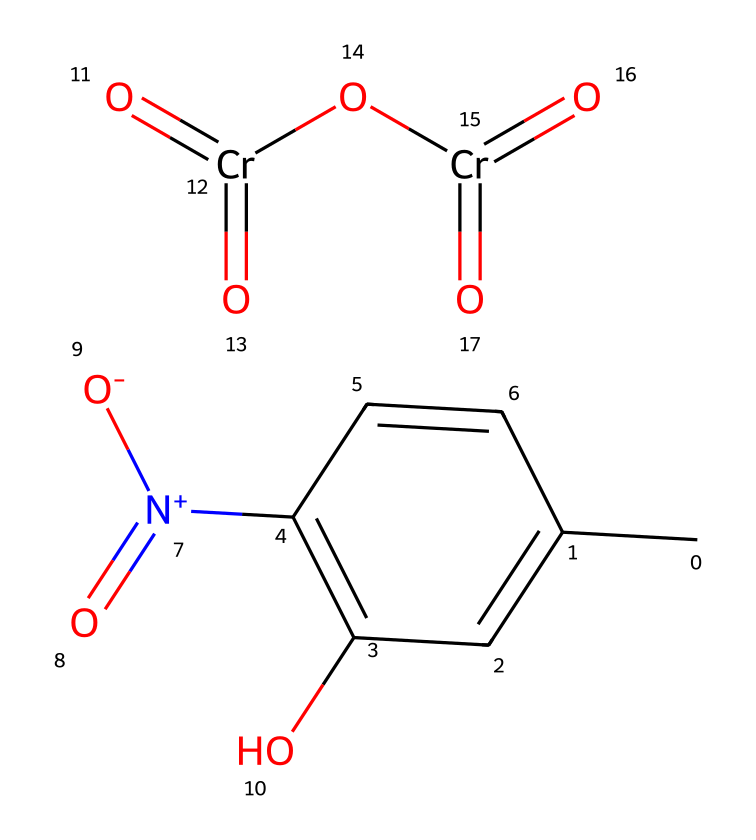What is the main color indicated by the presence of chromium in this chemical? The chromium atoms are often associated with green coloring in ceramics due to their oxidation states and how they absorb visible light.
Answer: green How many nitrogen atoms are present in this chemical? By analyzing the SMILES representation, there is one nitrogen atom represented in the chemical structure.
Answer: one What functional groups can be identified in the chemical structure? The structure contains a hydroxyl group (-OH), a nitro group (-NO2), and a chromate group (Cr=O) which are key functional groups influencing its properties.
Answer: hydroxyl, nitro, chromate How many oxygen atoms are in the molecule? By counting the oxygen atoms from the different groups in the structure (e.g., nitro group, chromate), we find a total of eight oxygen atoms.
Answer: eight What type of bond involves the chromium in the chemical structure? The chromium in this structure forms coordination bonds with oxygen, created through its interaction with surrounding oxygen atoms in the chromate moiety.
Answer: coordination What property of this ceramic pigment contributes to its use in colorful gaming accessories? The pigment's bright colors, particularly related to the metal ions and their effective light absorption properties, make it suitable for aesthetic applications in gaming accessories.
Answer: color brightness 